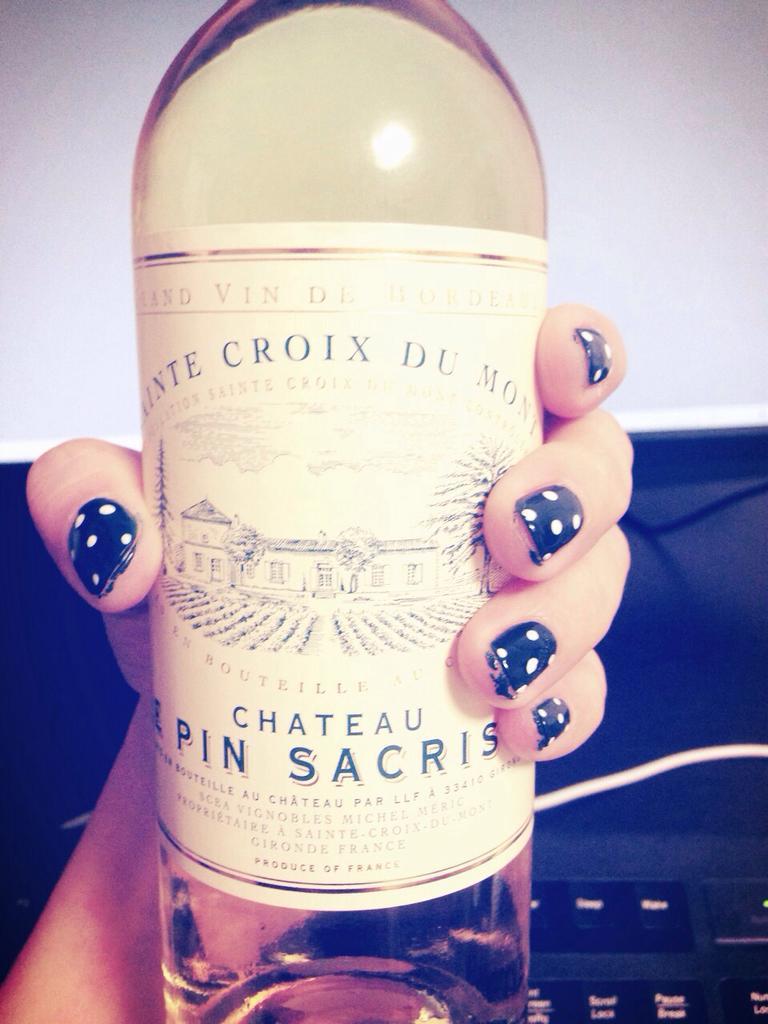Could you give a brief overview of what you see in this image? In this image I can see a hand of a person is holding a bottle. 